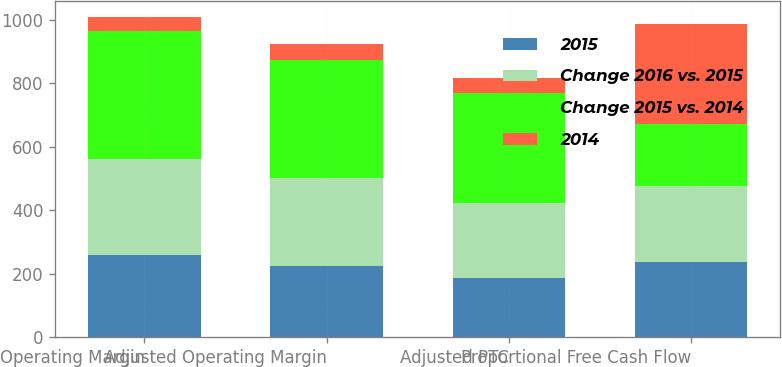Convert chart. <chart><loc_0><loc_0><loc_500><loc_500><stacked_bar_chart><ecel><fcel>Operating Margin<fcel>Adjusted Operating Margin<fcel>Adjusted PTC<fcel>Proportional Free Cash Flow<nl><fcel>2015<fcel>259<fcel>225<fcel>187<fcel>238<nl><fcel>Change 2016 vs. 2015<fcel>303<fcel>276<fcel>235<fcel>238<nl><fcel>Change 2015 vs. 2014<fcel>403<fcel>373<fcel>348<fcel>197<nl><fcel>2014<fcel>44<fcel>51<fcel>48<fcel>314<nl></chart> 